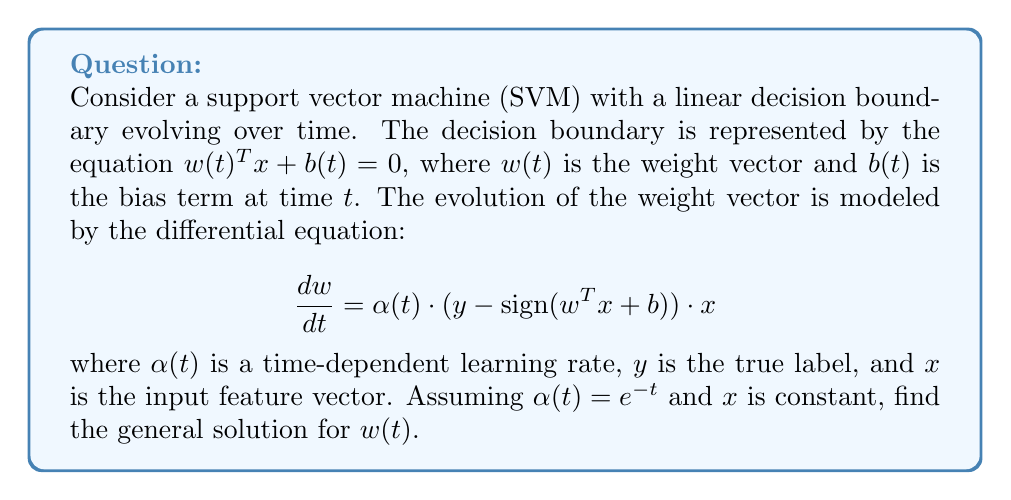Teach me how to tackle this problem. To solve this first-order differential equation, we'll follow these steps:

1) First, let's simplify the equation by recognizing that for a given training example, $(y - \text{sign}(w^T x + b))$ and $x$ are constants. Let's call their product $c$. So our equation becomes:

   $$\frac{dw}{dt} = c \cdot e^{-t}$$

2) This is a separable differential equation. We can rewrite it as:

   $$dw = c \cdot e^{-t} dt$$

3) Integrating both sides:

   $$\int dw = \int c \cdot e^{-t} dt$$

4) The left side integrates to $w$, and for the right side:

   $$w = -c \cdot e^{-t} + C$$

   where $C$ is the constant of integration.

5) To get the final form, we can write:

   $$w(t) = c \cdot e^{-t} + C$$

   where we've absorbed the negative sign into the constant $c$.

This is the general solution for $w(t)$. The constant $C$ represents the initial condition, which would be determined by the initial weight vector $w(0)$.
Answer: $w(t) = c \cdot e^{-t} + C$, where $c$ and $C$ are constants. 